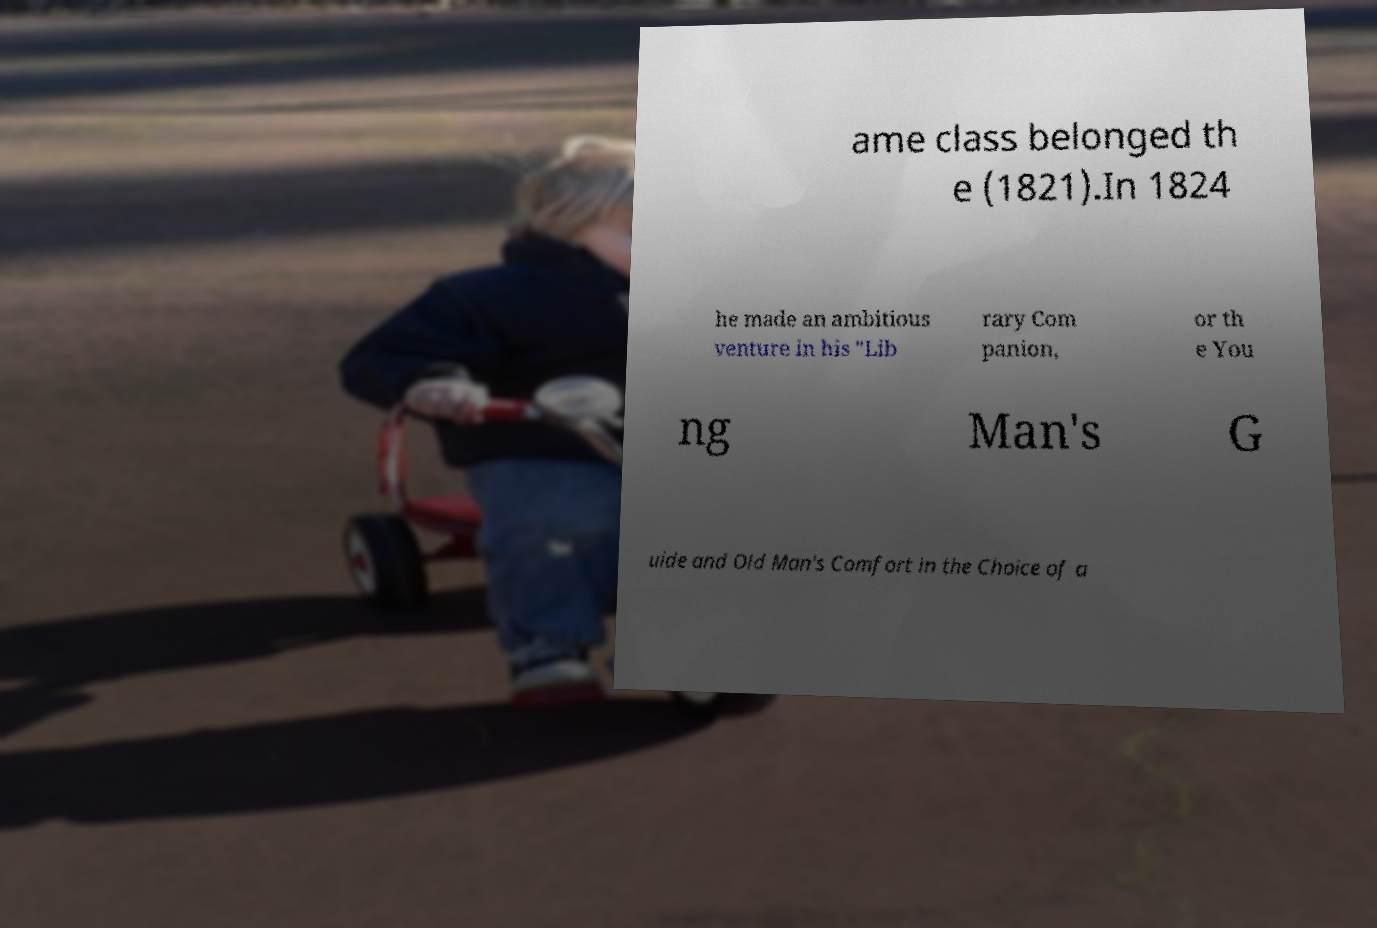Can you accurately transcribe the text from the provided image for me? ame class belonged th e (1821).In 1824 he made an ambitious venture in his "Lib rary Com panion, or th e You ng Man's G uide and Old Man's Comfort in the Choice of a 